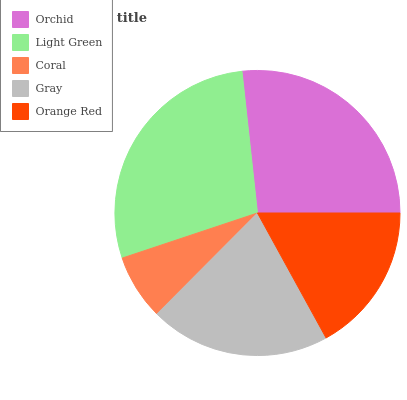Is Coral the minimum?
Answer yes or no. Yes. Is Light Green the maximum?
Answer yes or no. Yes. Is Light Green the minimum?
Answer yes or no. No. Is Coral the maximum?
Answer yes or no. No. Is Light Green greater than Coral?
Answer yes or no. Yes. Is Coral less than Light Green?
Answer yes or no. Yes. Is Coral greater than Light Green?
Answer yes or no. No. Is Light Green less than Coral?
Answer yes or no. No. Is Gray the high median?
Answer yes or no. Yes. Is Gray the low median?
Answer yes or no. Yes. Is Orchid the high median?
Answer yes or no. No. Is Orange Red the low median?
Answer yes or no. No. 